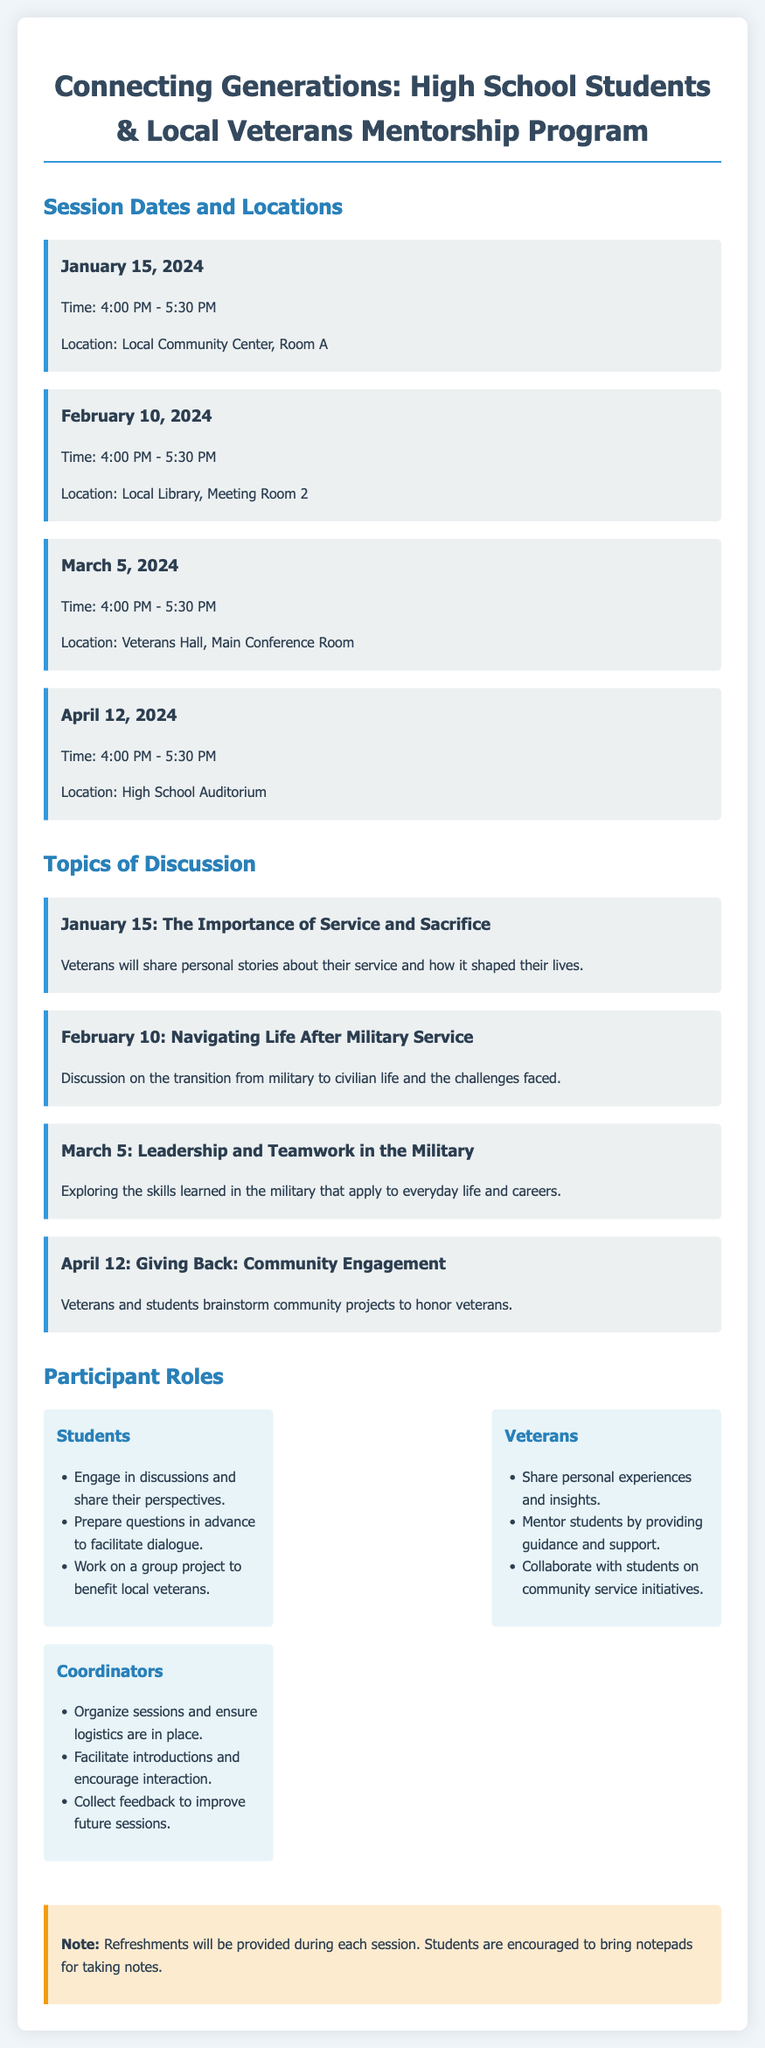What is the first session date? The first session date listed in the document is January 15, 2024.
Answer: January 15, 2024 What time does the April session start? The document states that the April session starts at 4:00 PM.
Answer: 4:00 PM Where will the February session take place? The February session is scheduled to take place at the Local Library, Meeting Room 2.
Answer: Local Library, Meeting Room 2 What is the main topic of the March session? The main topic of the March session is Leadership and Teamwork in the Military.
Answer: Leadership and Teamwork in the Military What role do students have in the program? Students are encouraged to engage in discussions and share their perspectives.
Answer: Engage in discussions and share their perspectives What will veterans do during the sessions? Veterans will share personal experiences and insights.
Answer: Share personal experiences and insights How many total sessions are scheduled in the agenda? The agenda includes a total of four sessions from January to April.
Answer: Four sessions What type of projects will be brainstormed during the April session? The April session will focus on brainstorming community projects to honor veterans.
Answer: Community projects to honor veterans Is there a note about refreshments? Yes, the document mentions that refreshments will be provided during each session.
Answer: Yes, refreshments will be provided 